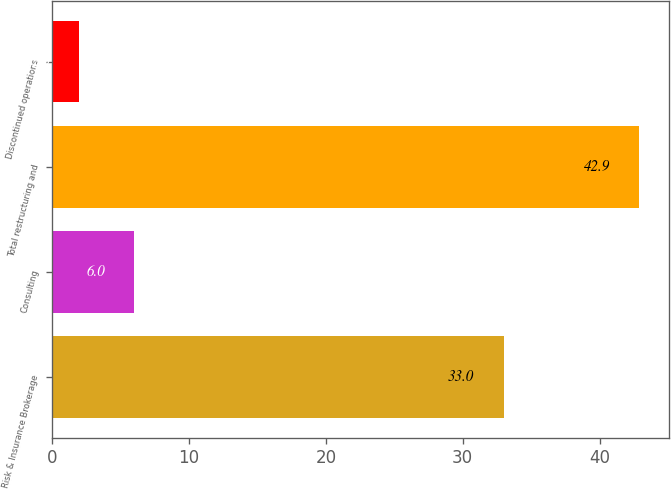<chart> <loc_0><loc_0><loc_500><loc_500><bar_chart><fcel>Risk & Insurance Brokerage<fcel>Consulting<fcel>Total restructuring and<fcel>Discontinued operations<nl><fcel>33<fcel>6<fcel>42.9<fcel>2<nl></chart> 